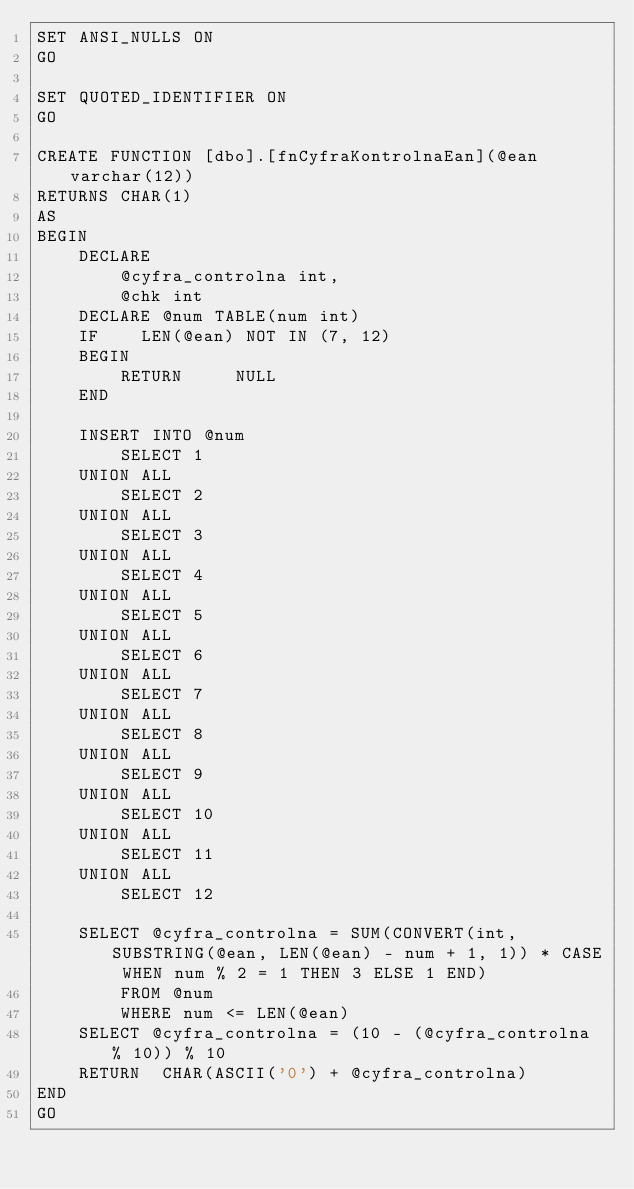Convert code to text. <code><loc_0><loc_0><loc_500><loc_500><_SQL_>SET ANSI_NULLS ON
GO

SET QUOTED_IDENTIFIER ON
GO

CREATE FUNCTION [dbo].[fnCyfraKontrolnaEan](@ean varchar(12))
RETURNS CHAR(1)
AS
BEGIN
    DECLARE
        @cyfra_controlna int,
        @chk int
    DECLARE @num TABLE(num int)
    IF    LEN(@ean) NOT IN (7, 12)
    BEGIN
        RETURN     NULL
    END

    INSERT INTO @num
        SELECT 1
    UNION ALL
        SELECT 2
    UNION ALL
        SELECT 3
    UNION ALL
        SELECT 4
    UNION ALL
        SELECT 5
    UNION ALL
        SELECT 6
    UNION ALL
        SELECT 7
    UNION ALL
        SELECT 8
    UNION ALL
        SELECT 9
    UNION ALL
        SELECT 10
    UNION ALL
        SELECT 11
    UNION ALL
        SELECT 12

    SELECT @cyfra_controlna = SUM(CONVERT(int, SUBSTRING(@ean, LEN(@ean) - num + 1, 1)) * CASE WHEN num % 2 = 1 THEN 3 ELSE 1 END)
        FROM @num
        WHERE num <= LEN(@ean)
    SELECT @cyfra_controlna = (10 - (@cyfra_controlna % 10)) % 10
    RETURN  CHAR(ASCII('0') + @cyfra_controlna)
END
GO
</code> 